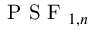<formula> <loc_0><loc_0><loc_500><loc_500>P S F _ { 1 , n }</formula> 